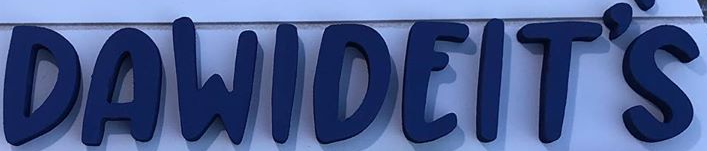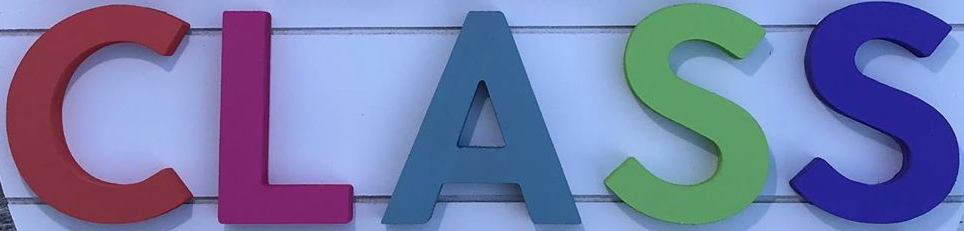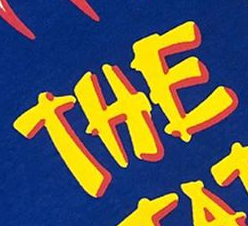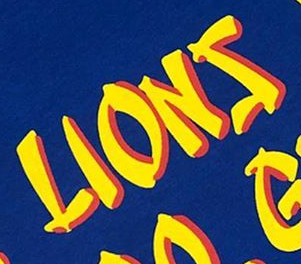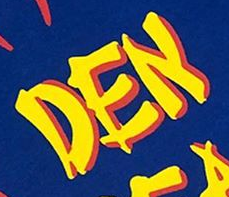What text is displayed in these images sequentially, separated by a semicolon? DAWIDEIT'S; CLASS; THE; LIONS; DEN 